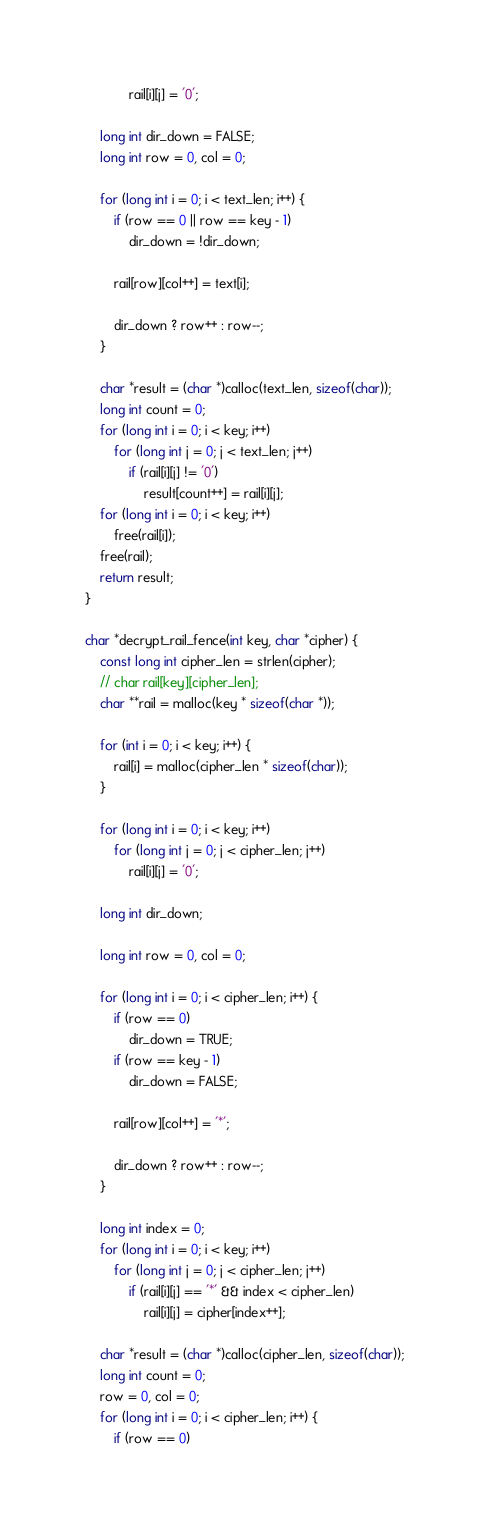Convert code to text. <code><loc_0><loc_0><loc_500><loc_500><_C_>            rail[i][j] = '0';

    long int dir_down = FALSE;
    long int row = 0, col = 0;

    for (long int i = 0; i < text_len; i++) {
        if (row == 0 || row == key - 1)
            dir_down = !dir_down;

        rail[row][col++] = text[i];

        dir_down ? row++ : row--;
    }

    char *result = (char *)calloc(text_len, sizeof(char));
    long int count = 0;
    for (long int i = 0; i < key; i++)
        for (long int j = 0; j < text_len; j++)
            if (rail[i][j] != '0')
                result[count++] = rail[i][j];
    for (long int i = 0; i < key; i++)
        free(rail[i]);
    free(rail);
    return result;
}

char *decrypt_rail_fence(int key, char *cipher) {
    const long int cipher_len = strlen(cipher);
    // char rail[key][cipher_len];
    char **rail = malloc(key * sizeof(char *));

    for (int i = 0; i < key; i++) {
        rail[i] = malloc(cipher_len * sizeof(char));
    }

    for (long int i = 0; i < key; i++)
        for (long int j = 0; j < cipher_len; j++)
            rail[i][j] = '0';

    long int dir_down;

    long int row = 0, col = 0;

    for (long int i = 0; i < cipher_len; i++) {
        if (row == 0)
            dir_down = TRUE;
        if (row == key - 1)
            dir_down = FALSE;

        rail[row][col++] = '*';

        dir_down ? row++ : row--;
    }

    long int index = 0;
    for (long int i = 0; i < key; i++)
        for (long int j = 0; j < cipher_len; j++)
            if (rail[i][j] == '*' && index < cipher_len)
                rail[i][j] = cipher[index++];

    char *result = (char *)calloc(cipher_len, sizeof(char));
    long int count = 0;
    row = 0, col = 0;
    for (long int i = 0; i < cipher_len; i++) {
        if (row == 0)</code> 